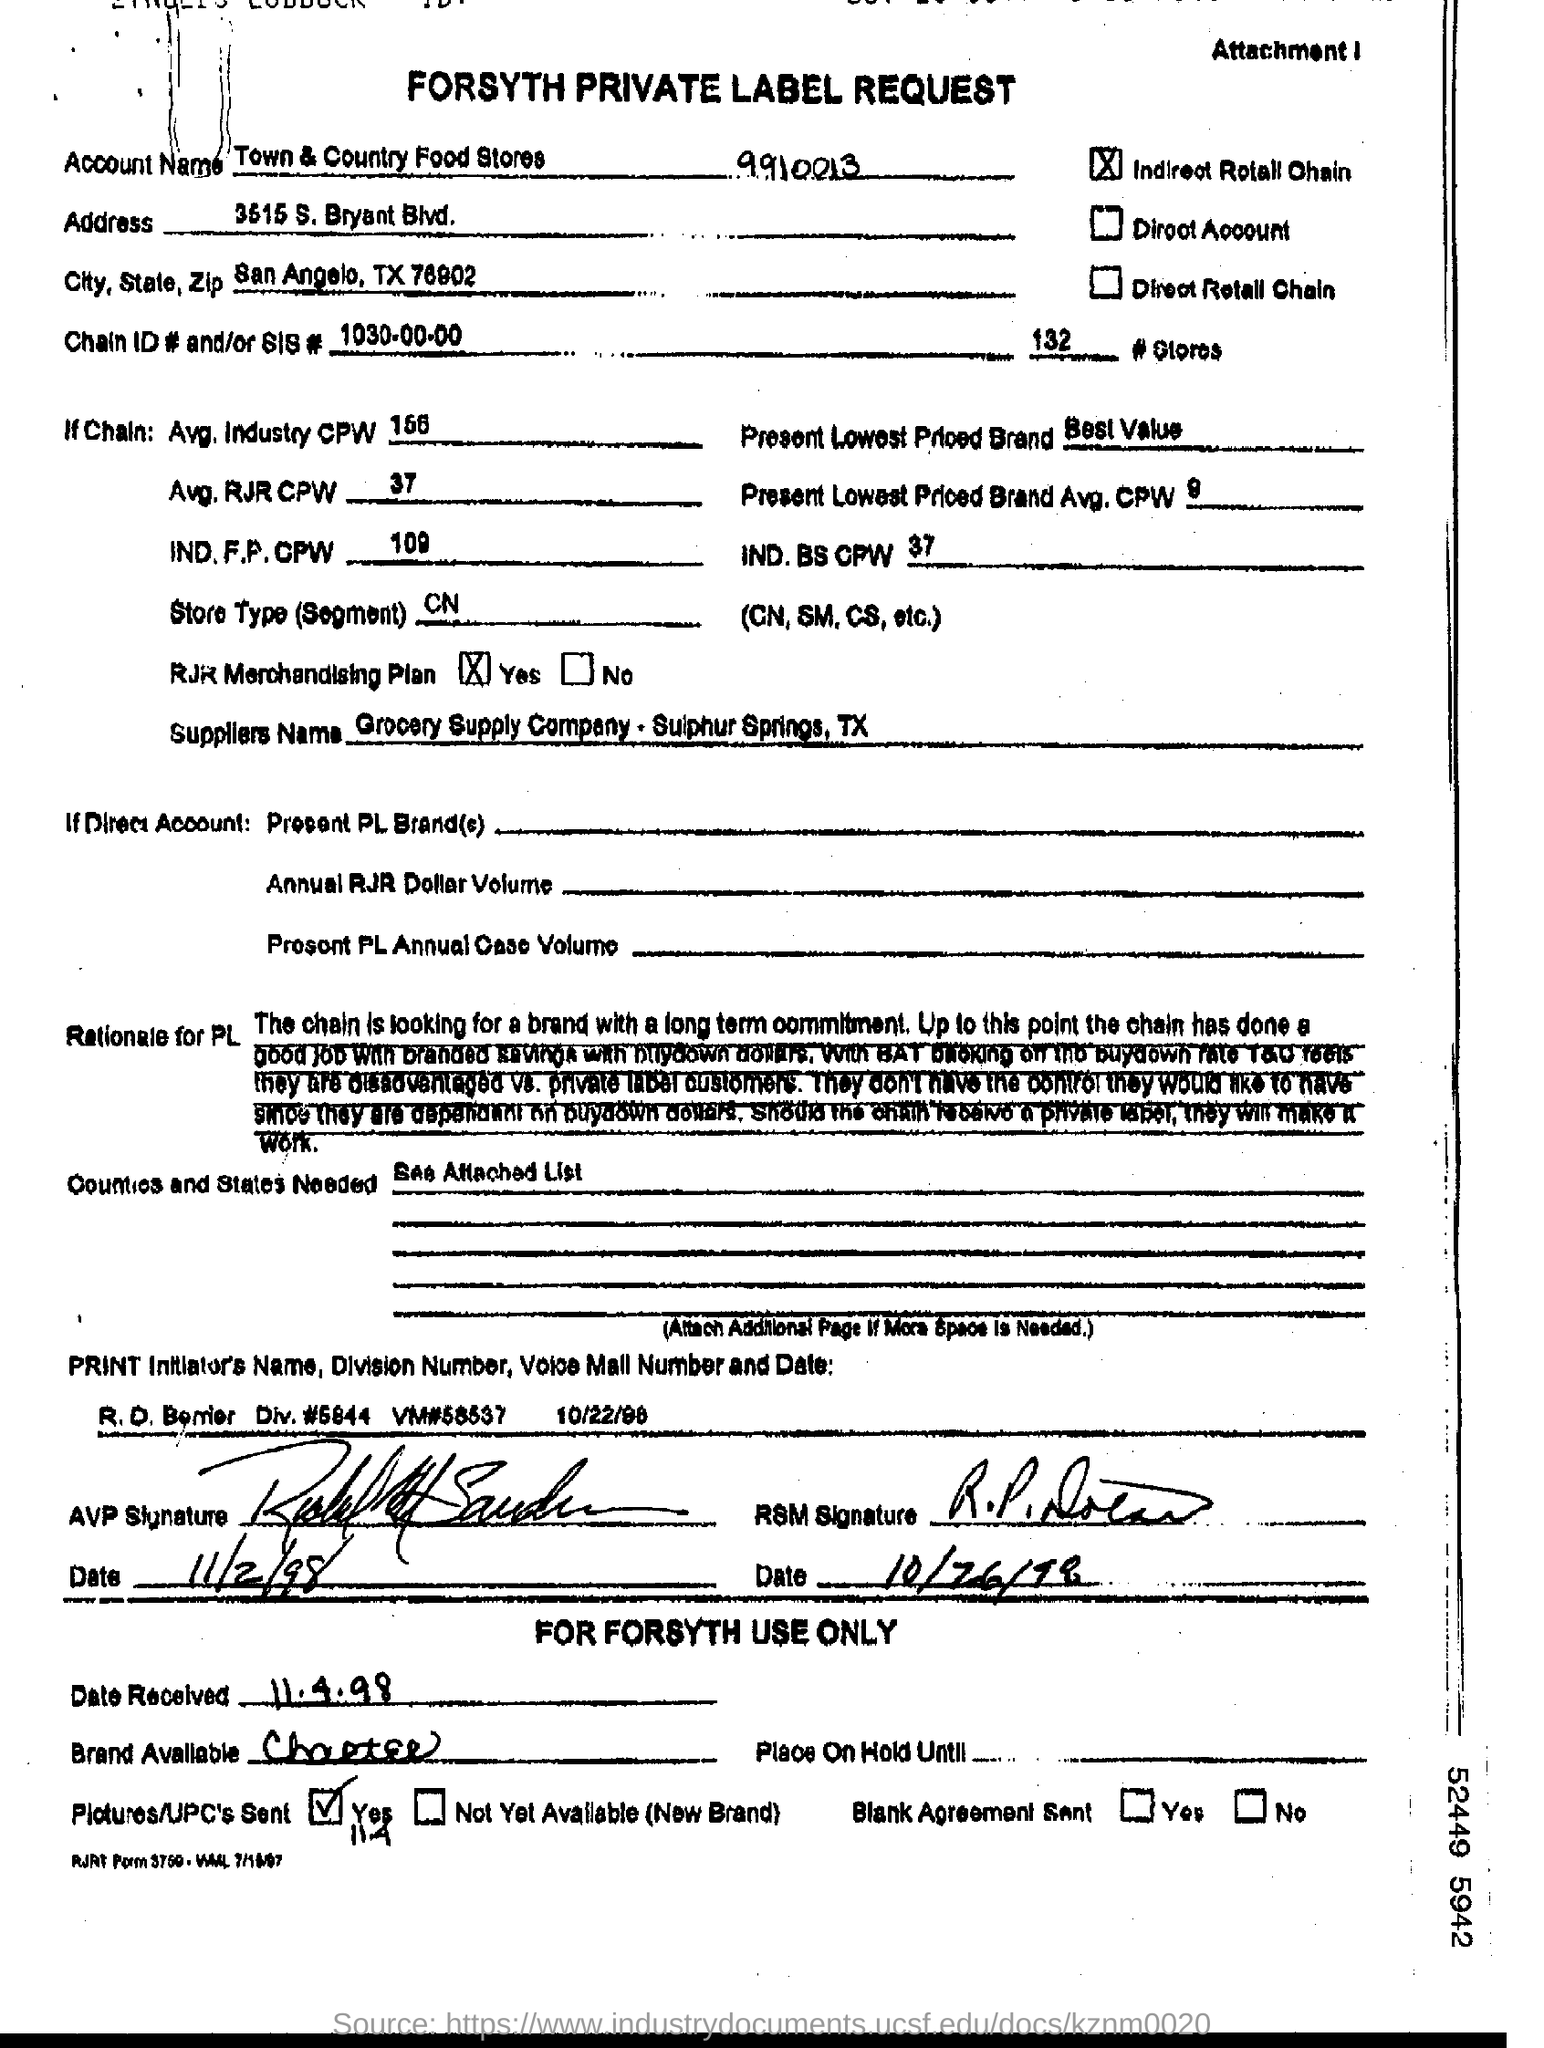Mention a couple of crucial points in this snapshot. The average industry cost per week (CPW) mentioned is 156. The mention of a date as the date received is considered dated. The RJR merchandising plan is Yes. 